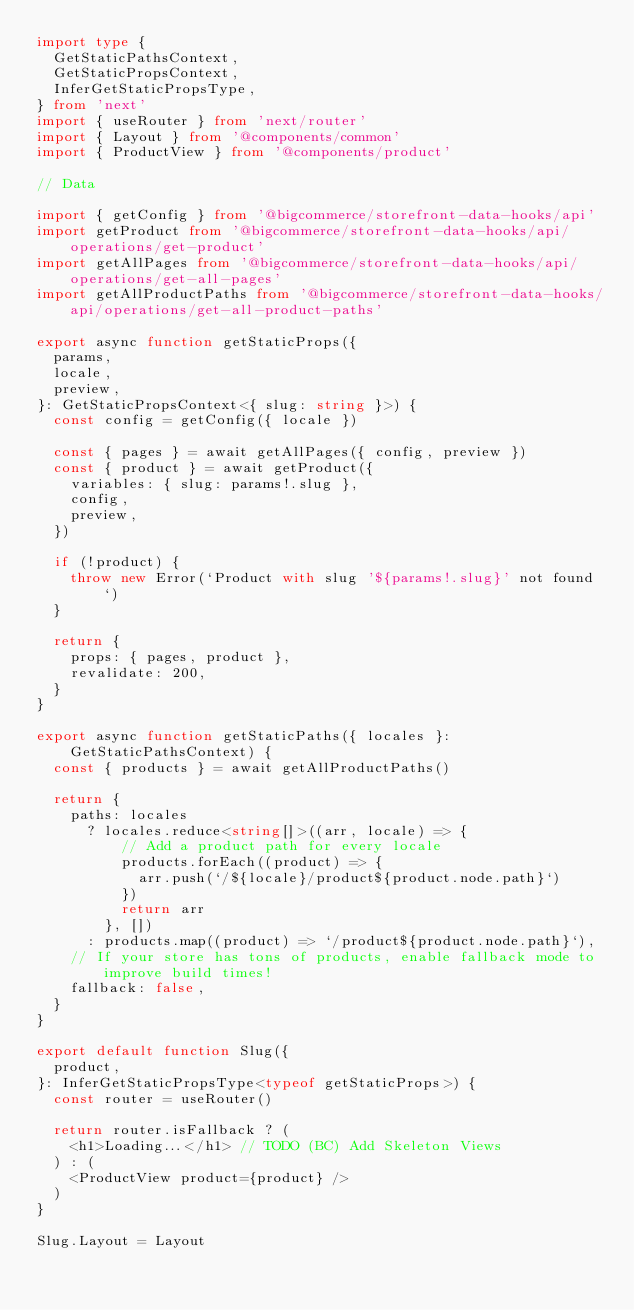Convert code to text. <code><loc_0><loc_0><loc_500><loc_500><_TypeScript_>import type {
  GetStaticPathsContext,
  GetStaticPropsContext,
  InferGetStaticPropsType,
} from 'next'
import { useRouter } from 'next/router'
import { Layout } from '@components/common'
import { ProductView } from '@components/product'

// Data

import { getConfig } from '@bigcommerce/storefront-data-hooks/api'
import getProduct from '@bigcommerce/storefront-data-hooks/api/operations/get-product'
import getAllPages from '@bigcommerce/storefront-data-hooks/api/operations/get-all-pages'
import getAllProductPaths from '@bigcommerce/storefront-data-hooks/api/operations/get-all-product-paths'

export async function getStaticProps({
  params,
  locale,
  preview,
}: GetStaticPropsContext<{ slug: string }>) {
  const config = getConfig({ locale })

  const { pages } = await getAllPages({ config, preview })
  const { product } = await getProduct({
    variables: { slug: params!.slug },
    config,
    preview,
  })

  if (!product) {
    throw new Error(`Product with slug '${params!.slug}' not found`)
  }

  return {
    props: { pages, product },
    revalidate: 200,
  }
}

export async function getStaticPaths({ locales }: GetStaticPathsContext) {
  const { products } = await getAllProductPaths()

  return {
    paths: locales
      ? locales.reduce<string[]>((arr, locale) => {
          // Add a product path for every locale
          products.forEach((product) => {
            arr.push(`/${locale}/product${product.node.path}`)
          })
          return arr
        }, [])
      : products.map((product) => `/product${product.node.path}`),
    // If your store has tons of products, enable fallback mode to improve build times!
    fallback: false,
  }
}

export default function Slug({
  product,
}: InferGetStaticPropsType<typeof getStaticProps>) {
  const router = useRouter()

  return router.isFallback ? (
    <h1>Loading...</h1> // TODO (BC) Add Skeleton Views
  ) : (
    <ProductView product={product} />
  )
}

Slug.Layout = Layout
</code> 